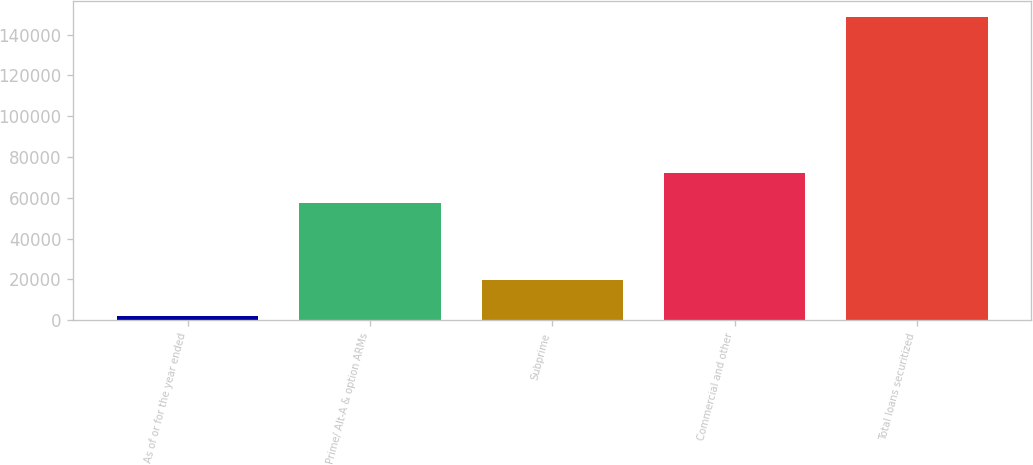Convert chart. <chart><loc_0><loc_0><loc_500><loc_500><bar_chart><fcel>As of or for the year ended<fcel>Prime/ Alt-A & option ARMs<fcel>Subprime<fcel>Commercial and other<fcel>Total loans securitized<nl><fcel>2016<fcel>57543<fcel>19903<fcel>72232.4<fcel>148910<nl></chart> 